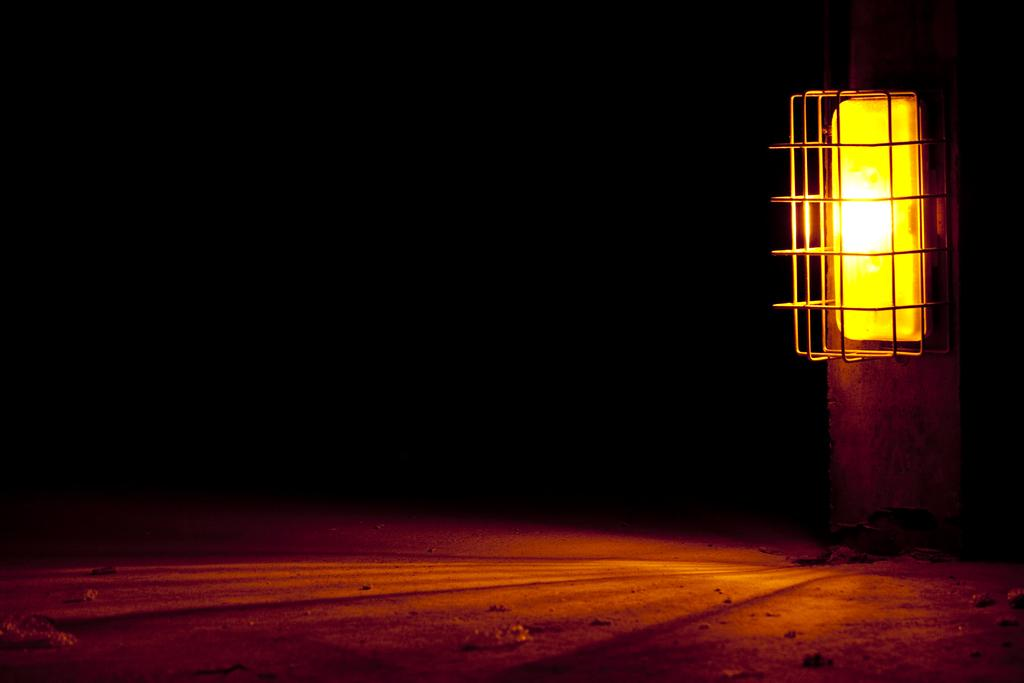What time of day is the image taken? The image is taken during night mode. What is the source of light in the image? There is a light on a pole in the image. What can be seen at the bottom of the image? The ground is visible at the bottom of the image. What type of fan is being used to write on the ground in the image? There is no fan present in the image, and no writing on the ground is visible. 